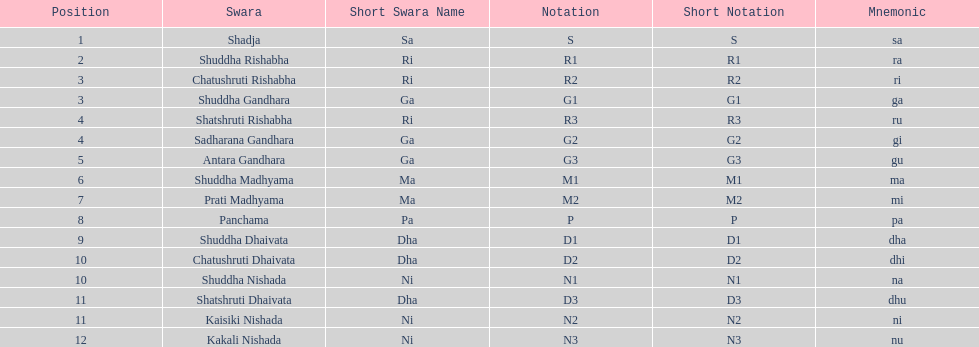Parse the table in full. {'header': ['Position', 'Swara', 'Short Swara Name', 'Notation', 'Short Notation', 'Mnemonic'], 'rows': [['1', 'Shadja', 'Sa', 'S', 'S', 'sa'], ['2', 'Shuddha Rishabha', 'Ri', 'R1', 'R1', 'ra'], ['3', 'Chatushruti Rishabha', 'Ri', 'R2', 'R2', 'ri'], ['3', 'Shuddha Gandhara', 'Ga', 'G1', 'G1', 'ga'], ['4', 'Shatshruti Rishabha', 'Ri', 'R3', 'R3', 'ru'], ['4', 'Sadharana Gandhara', 'Ga', 'G2', 'G2', 'gi'], ['5', 'Antara Gandhara', 'Ga', 'G3', 'G3', 'gu'], ['6', 'Shuddha Madhyama', 'Ma', 'M1', 'M1', 'ma'], ['7', 'Prati Madhyama', 'Ma', 'M2', 'M2', 'mi'], ['8', 'Panchama', 'Pa', 'P', 'P', 'pa'], ['9', 'Shuddha Dhaivata', 'Dha', 'D1', 'D1', 'dha'], ['10', 'Chatushruti Dhaivata', 'Dha', 'D2', 'D2', 'dhi'], ['10', 'Shuddha Nishada', 'Ni', 'N1', 'N1', 'na'], ['11', 'Shatshruti Dhaivata', 'Dha', 'D3', 'D3', 'dhu'], ['11', 'Kaisiki Nishada', 'Ni', 'N2', 'N2', 'ni'], ['12', 'Kakali Nishada', 'Ni', 'N3', 'N3', 'nu']]} List each pair of swaras that share the same position. Chatushruti Rishabha, Shuddha Gandhara, Shatshruti Rishabha, Sadharana Gandhara, Chatushruti Dhaivata, Shuddha Nishada, Shatshruti Dhaivata, Kaisiki Nishada. 